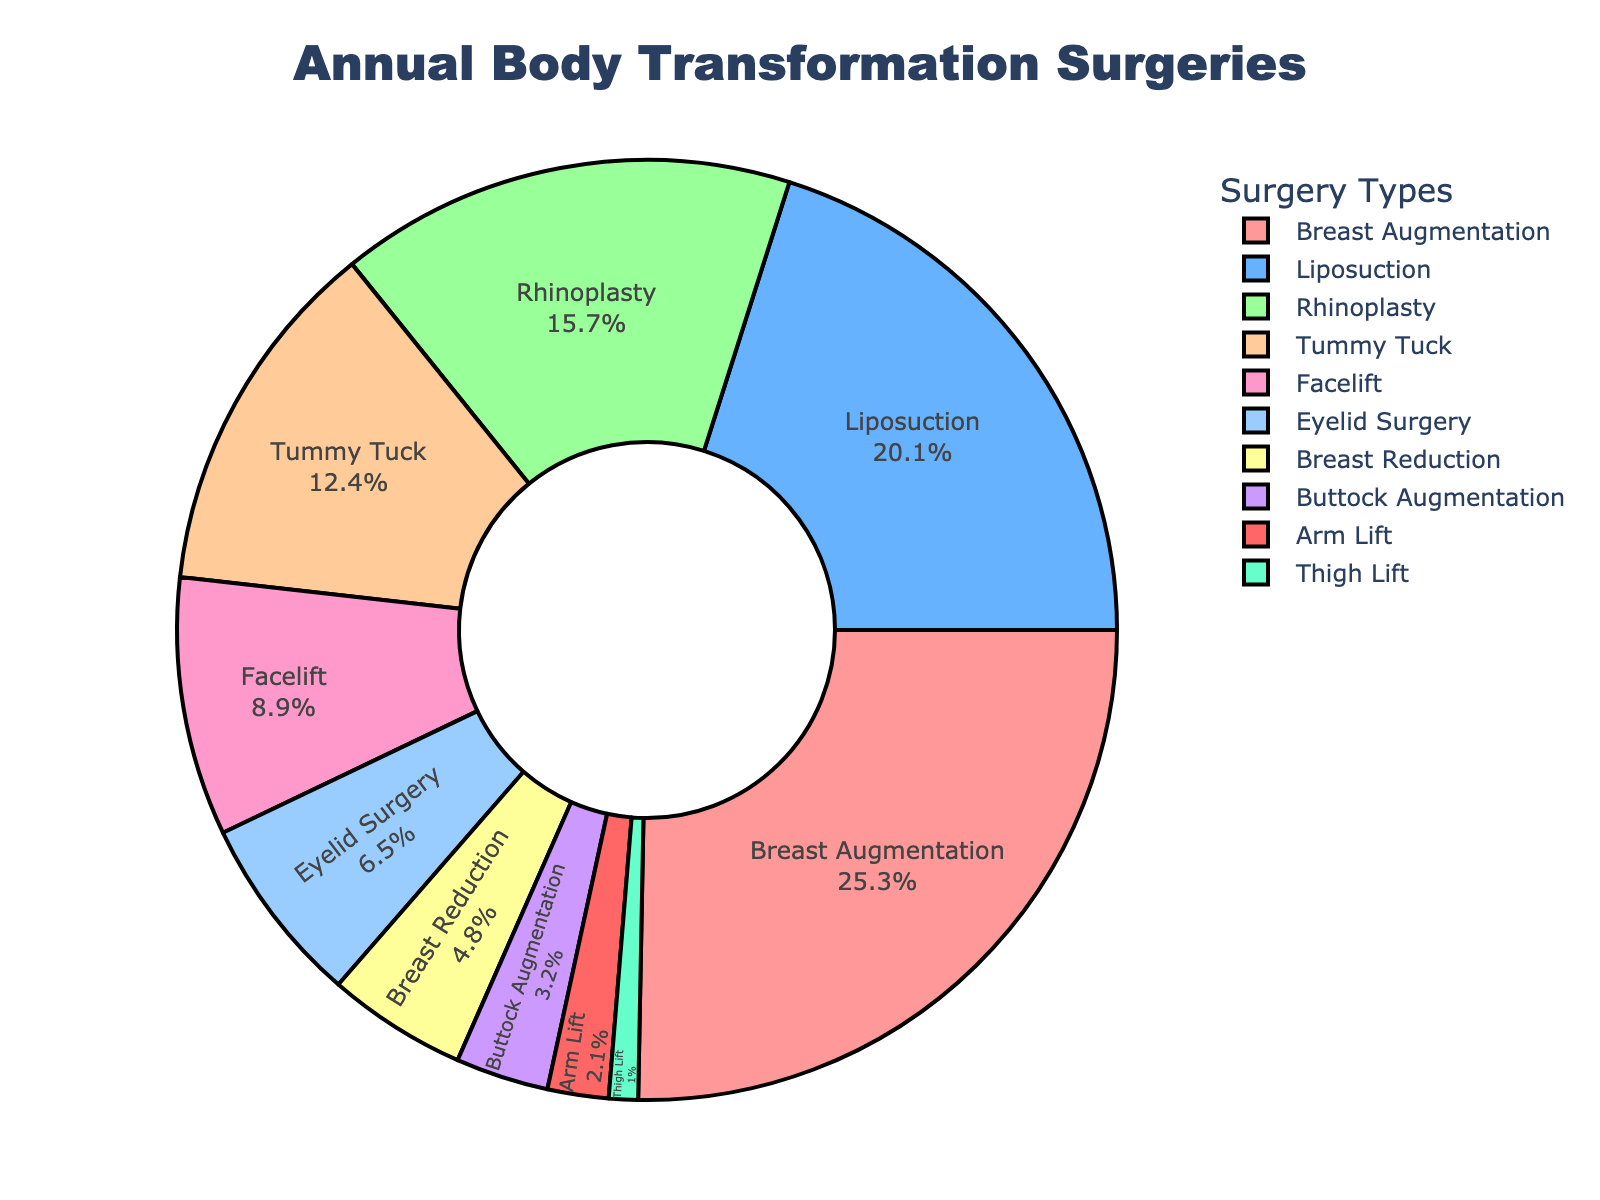Which type of body transformation surgery has the highest proportion? The figure displays a pie chart with the proportion of different types of surgeries. By visually inspecting the segments, the 'Breast Augmentation' section is the largest.
Answer: Breast Augmentation How much larger is the Breast Augmentation proportion compared to Buttock Augmentation? The Breast Augmentation proportion is 25.3%, and the Buttock Augmentation proportion is 3.2%. The difference can be calculated as 25.3% - 3.2% = 22.1%.
Answer: 22.1% Which surgeries have a proportion of less than 5% annually? By identifying the pie chart segments with proportions under 5%, we find the types of surgeries: Breast Reduction (4.8%), Buttock Augmentation (3.2%), Arm Lift (2.1%), and Thigh Lift (1.0%).
Answer: Breast Reduction, Buttock Augmentation, Arm Lift, Thigh Lift Combine the proportions of Rhinoplasty and Tummy Tuck; which major surgery type does their sum closely match? Rhinoplasty (15.7%) and Tummy Tuck (12.4%) add up to 15.7% + 12.4% = 28.1%. The combined proportion is closest to Breast Augmentation (25.3%).
Answer: Breast Augmentation What is the combined percentage of Eyelid Surgery, Breast Reduction, and Buttock Augmentation? Eyelid Surgery has 6.5%, Breast Reduction has 4.8%, and Buttock Augmentation has 3.2%. Sum: 6.5% + 4.8% + 3.2% = 14.5%.
Answer: 14.5% Which surgeries, when combined, make up approximately one-third of the total proportion of surgeries performed annually? One-third of the total proportion is approximately 33.3%. Combining Breast Augmentation (25.3%) and Arm Lift (2.1%) gives us 25.3% + 2.1% = 27.4%. Adding Eyelid Surgery (6.5%) brings the total to 27.4% + 6.5% = 33.9%, which is close to one-third.
Answer: Breast Augmentation, Arm Lift, Eyelid Surgery 